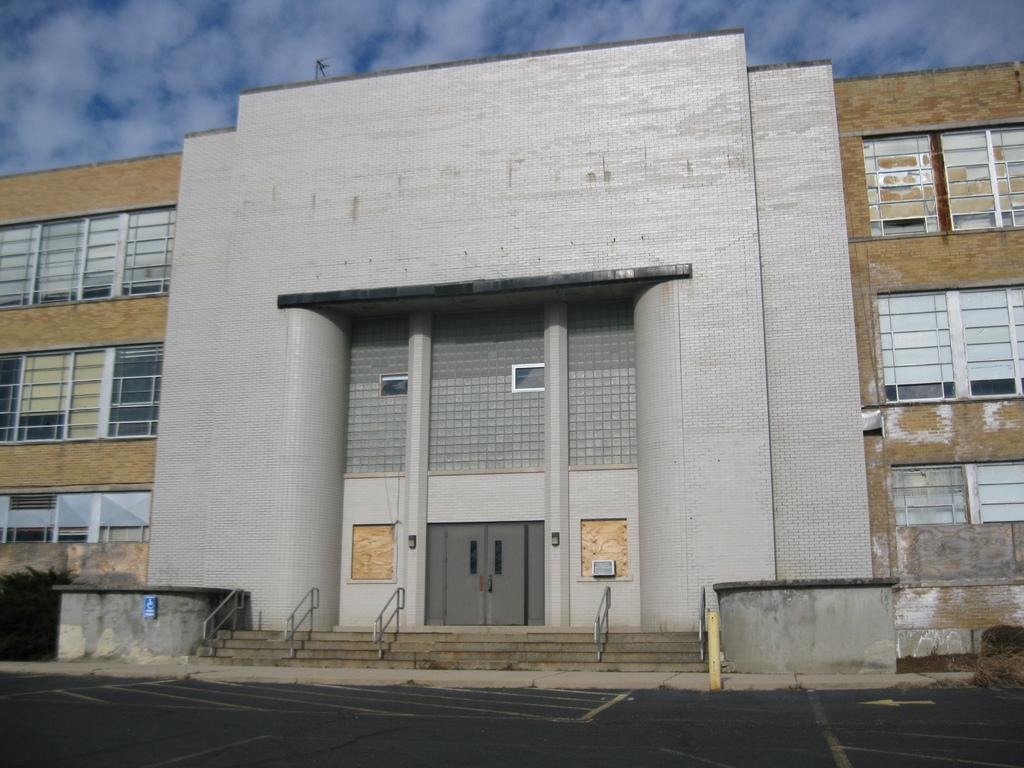What type of building is shown in the image? There is a building with glass windows in the image. Can you identify any specific features of the building? Yes, there is a door visible in the image. How can people access the different levels of the building? There are railing stairs in the image. What is visible in the sky in the image? Clouds are present in the sky in the image. What type of farm animals can be seen grazing in the image? There is no farm or farm animals present in the image; it features a building with glass windows, a door, railing stairs, and clouds in the sky. What color is the thread used to sew the print on the building? There is no print or thread present in the image. 